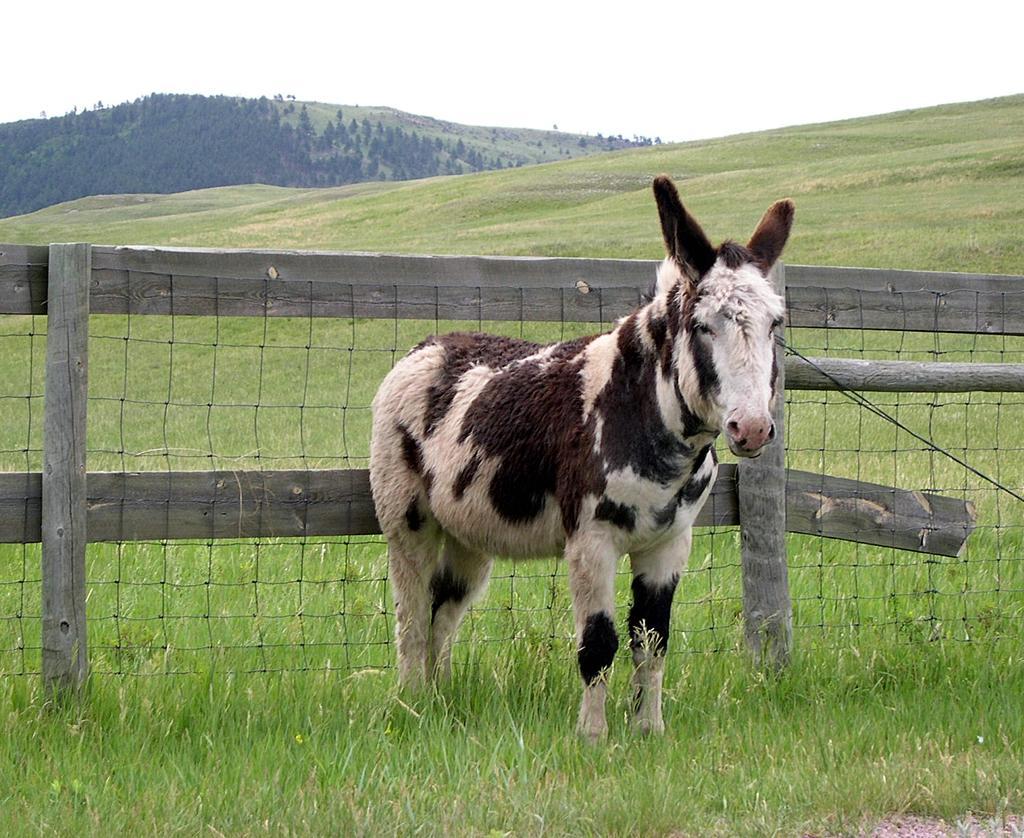In one or two sentences, can you explain what this image depicts? In this image there is the sky towards the top of the image, there is a mountain, there are trees on the mountain, there is grass, there is a fence, there is an animal, there is an object towards the right of the image that looks like a wire. 